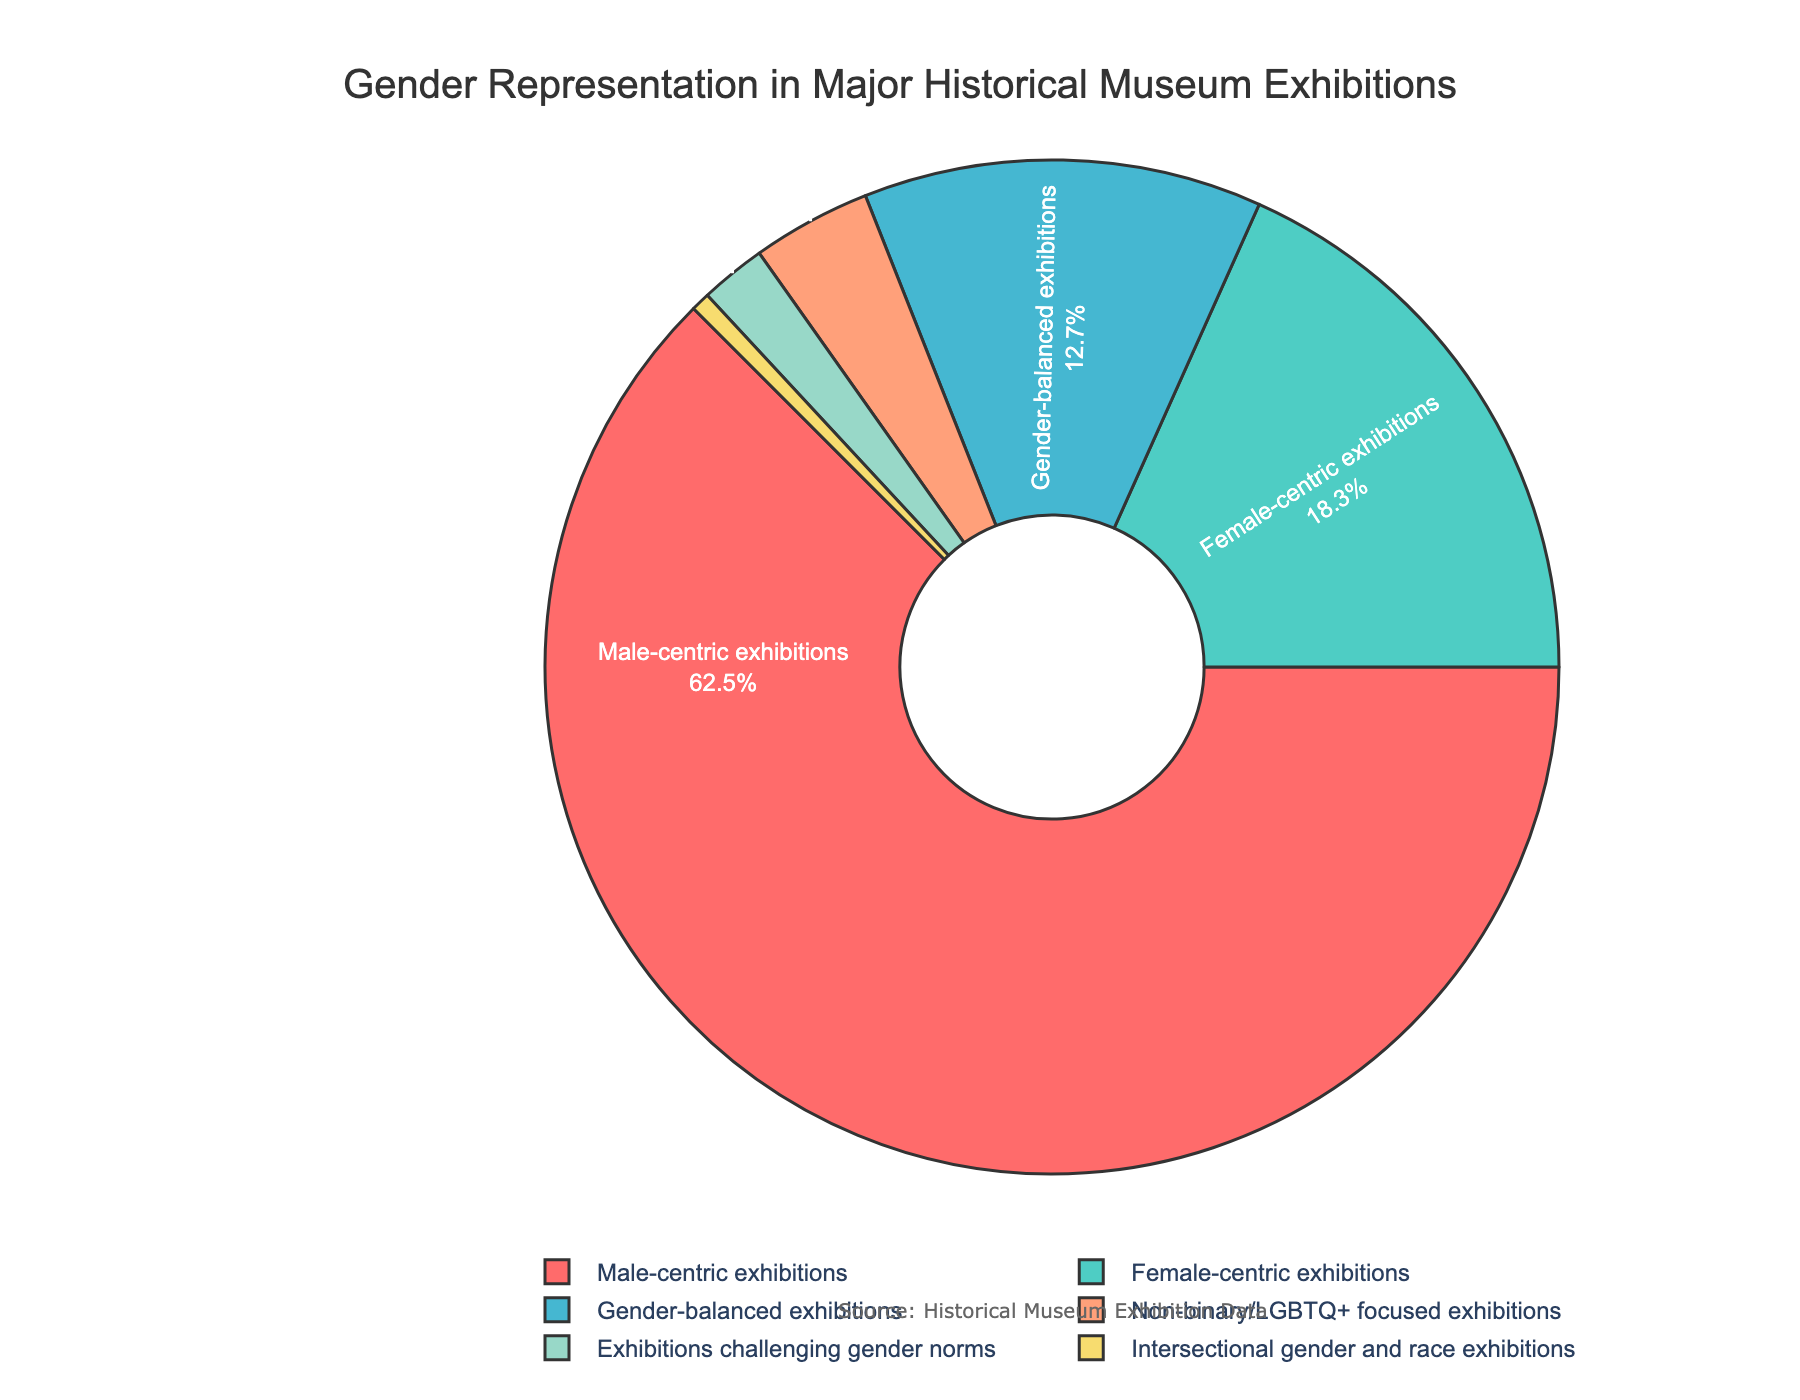What percentage of exhibitions are gender-balanced? This can be directly observed on the pie chart where the percentage for gender-balanced exhibitions is labeled.
Answer: 12.7% Which category of exhibitions has the least representation? By comparing the percentages of all categories, the one with the smallest percentage is identified, which is intersectional gender and race exhibitions.
Answer: Intersectional gender and race exhibitions What is the combined percentage of female-centric and non-binary/LGBTQ+ focused exhibitions? Add the percentages of female-centric exhibitions (18.3%) and non-binary/LGBTQ+ focused exhibitions (3.8%): 18.3 + 3.8.
Answer: 22.1% How does the percentage of male-centric exhibitions compare with gender-balanced exhibitions? Compare the values given: male-centric (62.5%) is greater than gender-balanced (12.7%).
Answer: Male-centric exhibitions have a higher percentage than gender-balanced exhibitions Which category has a higher representation, female-centric or exhibitions challenging gender norms? Compare the percentages: female-centric exhibitions (18.3%) is higher than exhibitions challenging gender norms (2.1%).
Answer: Female-centric exhibitions What is the ratio of male-centric to female-centric exhibitions? Divide the percentage of male-centric exhibitions (62.5%) by the percentage of female-centric exhibitions (18.3%): 62.5 / 18.3.
Answer: 3.42 (approx) What color represents the gender-balanced exhibitions in the pie chart? Identify the color associated with the gender-balanced exhibitions label in the chart.
Answer: Light blue What is the overall percentage of exhibitions focusing specifically on gender norms, including both challenging gender norms and intersectional gender and race exhibitions? Add the percentages of exhibitions challenging gender norms (2.1%) and intersectional gender and race exhibitions (0.6%): 2.1 + 0.6.
Answer: 2.7% Which category has the second highest representation? Identify the category with the second highest percentage after male-centric exhibitions: female-centric exhibitions at 18.3%.
Answer: Female-centric exhibitions How much greater is the representation of male-centric exhibitions compared to exhibitions challenging gender norms? Subtract the percentage of exhibitions challenging gender norms (2.1%) from the percentage of male-centric exhibitions (62.5%): 62.5 - 2.1.
Answer: 60.4% 